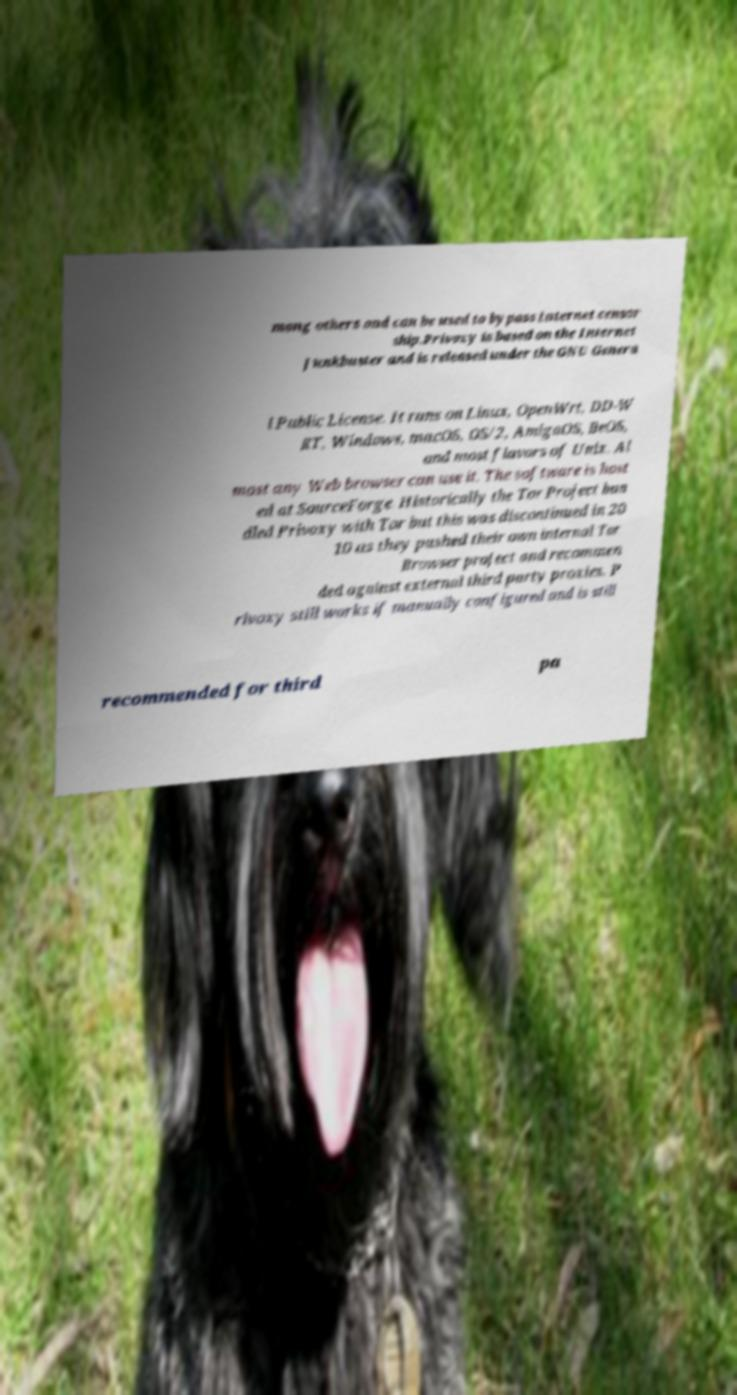For documentation purposes, I need the text within this image transcribed. Could you provide that? mong others and can be used to bypass Internet censor ship.Privoxy is based on the Internet Junkbuster and is released under the GNU Genera l Public License. It runs on Linux, OpenWrt, DD-W RT, Windows, macOS, OS/2, AmigaOS, BeOS, and most flavors of Unix. Al most any Web browser can use it. The software is host ed at SourceForge. Historically the Tor Project bun dled Privoxy with Tor but this was discontinued in 20 10 as they pushed their own internal Tor Browser project and recommen ded against external third party proxies. P rivoxy still works if manually configured and is still recommended for third pa 